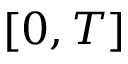Convert formula to latex. <formula><loc_0><loc_0><loc_500><loc_500>[ 0 , T ]</formula> 